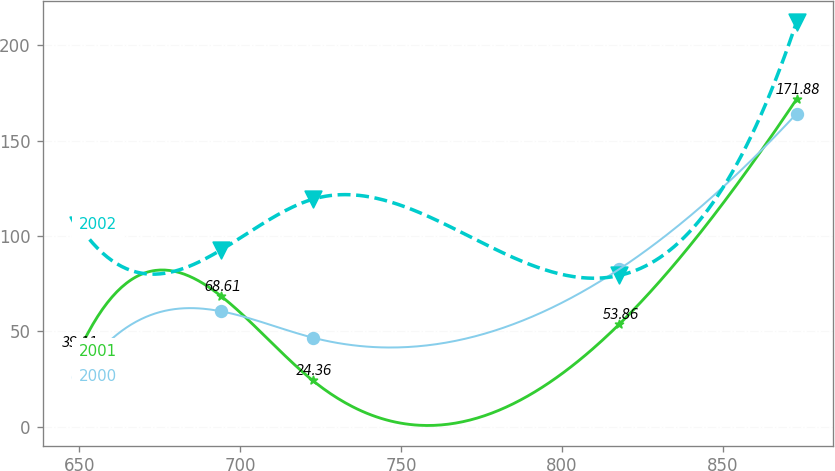<chart> <loc_0><loc_0><loc_500><loc_500><line_chart><ecel><fcel>2001<fcel>2000<fcel>2002<nl><fcel>649.67<fcel>39.11<fcel>26.16<fcel>105.99<nl><fcel>693.95<fcel>68.61<fcel>60.58<fcel>92.68<nl><fcel>722.45<fcel>24.36<fcel>46.77<fcel>119.3<nl><fcel>817.88<fcel>53.86<fcel>82.73<fcel>79.37<nl><fcel>873<fcel>171.88<fcel>164.27<fcel>212.49<nl></chart> 